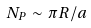Convert formula to latex. <formula><loc_0><loc_0><loc_500><loc_500>N _ { P } \sim \pi R / a</formula> 